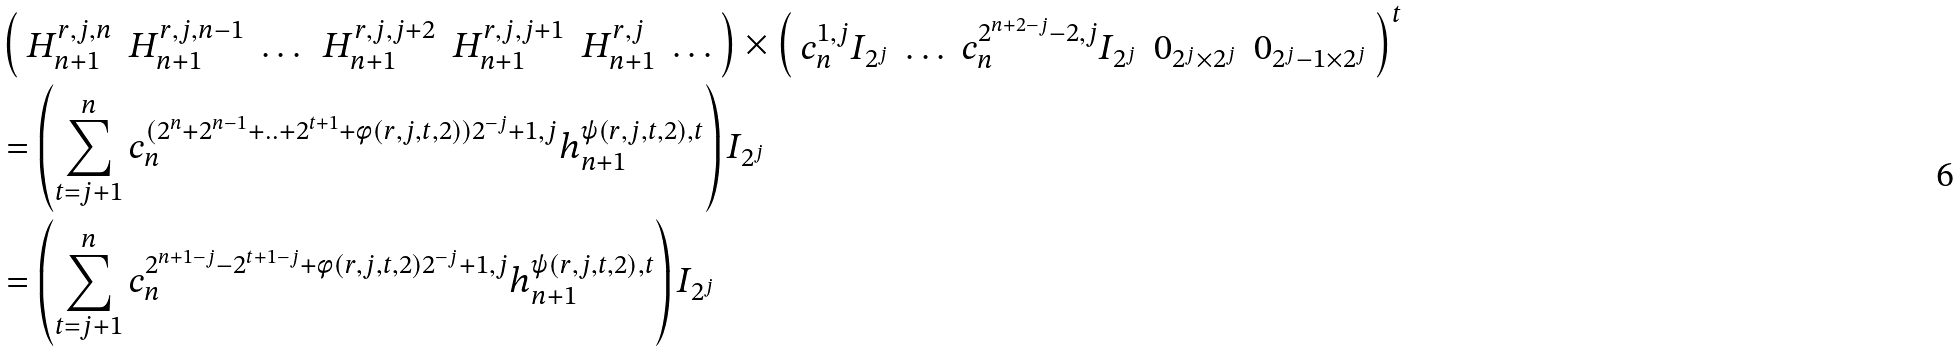Convert formula to latex. <formula><loc_0><loc_0><loc_500><loc_500>& \left ( \begin{array} { c c c c c c c } H ^ { r , j , n } _ { n + 1 } & H ^ { r , j , n - 1 } _ { n + 1 } & \dots & H ^ { r , j , j + 2 } _ { n + 1 } & H ^ { r , j , j + 1 } _ { n + 1 } & H ^ { r , j } _ { n + 1 } & \dots \end{array} \right ) \times \left ( \begin{array} { c c c c c } c ^ { 1 , j } _ { n } I _ { 2 ^ { j } } & \hdots & c ^ { 2 ^ { n + 2 - j } - 2 , j } _ { n } I _ { 2 ^ { j } } & 0 _ { 2 ^ { j } \times 2 ^ { j } } & 0 _ { 2 ^ { j } - 1 \times 2 ^ { j } } \end{array} \right ) ^ { t } \\ & = \left ( \sum _ { t = j + 1 } ^ { n } c ^ { ( 2 ^ { n } + 2 ^ { n - 1 } + . . + 2 ^ { t + 1 } + \phi ( r , j , t , 2 ) ) 2 ^ { - j } + 1 , j } _ { n } h ^ { \psi ( r , j , t , 2 ) , t } _ { n + 1 } \right ) I _ { 2 ^ { j } } \\ & = \left ( \sum _ { t = j + 1 } ^ { n } c ^ { 2 ^ { n + 1 - j } - 2 ^ { t + 1 - j } + \phi ( r , j , t , 2 ) 2 ^ { - j } + 1 , j } _ { n } h ^ { \psi ( r , j , t , 2 ) , t } _ { n + 1 } \right ) I _ { 2 ^ { j } } \\</formula> 